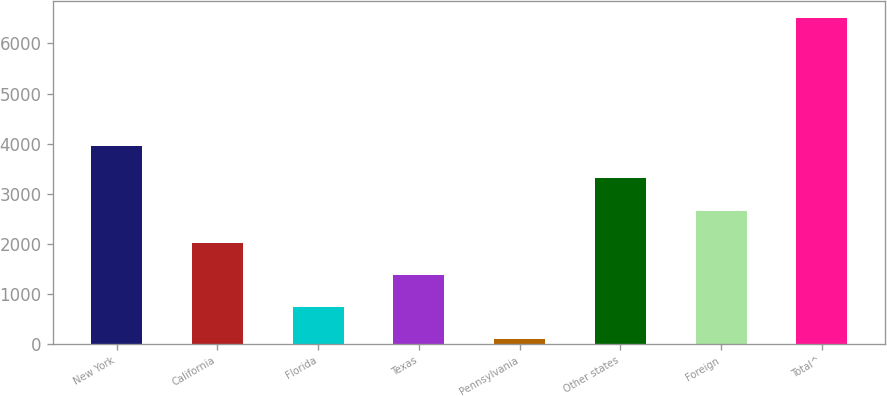<chart> <loc_0><loc_0><loc_500><loc_500><bar_chart><fcel>New York<fcel>California<fcel>Florida<fcel>Texas<fcel>Pennsylvania<fcel>Other states<fcel>Foreign<fcel>Total^<nl><fcel>3946.4<fcel>2017.7<fcel>731.9<fcel>1374.8<fcel>89<fcel>3303.5<fcel>2660.6<fcel>6518<nl></chart> 